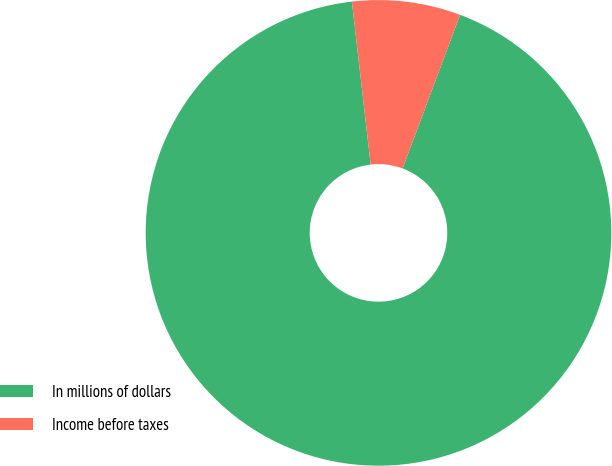<chart> <loc_0><loc_0><loc_500><loc_500><pie_chart><fcel>In millions of dollars<fcel>Income before taxes<nl><fcel>92.48%<fcel>7.52%<nl></chart> 